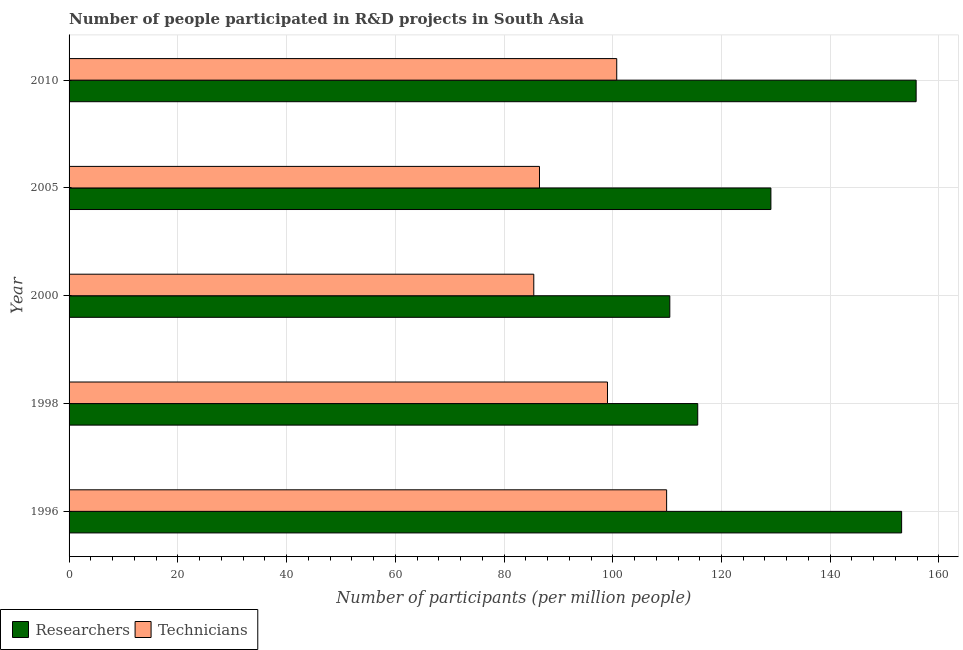How many different coloured bars are there?
Provide a succinct answer. 2. How many groups of bars are there?
Keep it short and to the point. 5. What is the number of technicians in 2010?
Give a very brief answer. 100.73. Across all years, what is the maximum number of researchers?
Provide a short and direct response. 155.8. Across all years, what is the minimum number of technicians?
Provide a succinct answer. 85.47. What is the total number of researchers in the graph?
Your answer should be very brief. 664.15. What is the difference between the number of technicians in 1996 and that in 2005?
Your answer should be very brief. 23.39. What is the difference between the number of researchers in 2010 and the number of technicians in 2000?
Offer a very short reply. 70.33. What is the average number of technicians per year?
Ensure brevity in your answer.  96.33. In the year 1996, what is the difference between the number of technicians and number of researchers?
Offer a terse response. -43.22. In how many years, is the number of researchers greater than 72 ?
Provide a succinct answer. 5. What is the ratio of the number of technicians in 1996 to that in 2000?
Provide a short and direct response. 1.29. Is the number of technicians in 2000 less than that in 2005?
Provide a short and direct response. Yes. Is the difference between the number of researchers in 1996 and 2000 greater than the difference between the number of technicians in 1996 and 2000?
Keep it short and to the point. Yes. What is the difference between the highest and the second highest number of researchers?
Your response must be concise. 2.67. What is the difference between the highest and the lowest number of technicians?
Offer a very short reply. 24.44. In how many years, is the number of technicians greater than the average number of technicians taken over all years?
Keep it short and to the point. 3. What does the 1st bar from the top in 2000 represents?
Your answer should be compact. Technicians. What does the 2nd bar from the bottom in 2000 represents?
Give a very brief answer. Technicians. How many bars are there?
Your answer should be very brief. 10. Does the graph contain any zero values?
Your answer should be compact. No. Does the graph contain grids?
Your answer should be very brief. Yes. How many legend labels are there?
Provide a short and direct response. 2. What is the title of the graph?
Give a very brief answer. Number of people participated in R&D projects in South Asia. What is the label or title of the X-axis?
Your answer should be very brief. Number of participants (per million people). What is the label or title of the Y-axis?
Offer a very short reply. Year. What is the Number of participants (per million people) of Researchers in 1996?
Offer a very short reply. 153.13. What is the Number of participants (per million people) in Technicians in 1996?
Provide a succinct answer. 109.91. What is the Number of participants (per million people) in Researchers in 1998?
Offer a very short reply. 115.63. What is the Number of participants (per million people) of Technicians in 1998?
Offer a terse response. 99.03. What is the Number of participants (per million people) in Researchers in 2000?
Ensure brevity in your answer.  110.5. What is the Number of participants (per million people) in Technicians in 2000?
Provide a succinct answer. 85.47. What is the Number of participants (per million people) of Researchers in 2005?
Your response must be concise. 129.09. What is the Number of participants (per million people) in Technicians in 2005?
Make the answer very short. 86.52. What is the Number of participants (per million people) of Researchers in 2010?
Provide a short and direct response. 155.8. What is the Number of participants (per million people) in Technicians in 2010?
Your answer should be very brief. 100.73. Across all years, what is the maximum Number of participants (per million people) in Researchers?
Provide a succinct answer. 155.8. Across all years, what is the maximum Number of participants (per million people) of Technicians?
Offer a very short reply. 109.91. Across all years, what is the minimum Number of participants (per million people) in Researchers?
Your answer should be compact. 110.5. Across all years, what is the minimum Number of participants (per million people) in Technicians?
Your response must be concise. 85.47. What is the total Number of participants (per million people) of Researchers in the graph?
Keep it short and to the point. 664.15. What is the total Number of participants (per million people) in Technicians in the graph?
Offer a very short reply. 481.67. What is the difference between the Number of participants (per million people) of Researchers in 1996 and that in 1998?
Ensure brevity in your answer.  37.5. What is the difference between the Number of participants (per million people) in Technicians in 1996 and that in 1998?
Ensure brevity in your answer.  10.88. What is the difference between the Number of participants (per million people) of Researchers in 1996 and that in 2000?
Provide a short and direct response. 42.63. What is the difference between the Number of participants (per million people) in Technicians in 1996 and that in 2000?
Ensure brevity in your answer.  24.44. What is the difference between the Number of participants (per million people) in Researchers in 1996 and that in 2005?
Provide a short and direct response. 24.04. What is the difference between the Number of participants (per million people) of Technicians in 1996 and that in 2005?
Provide a short and direct response. 23.39. What is the difference between the Number of participants (per million people) of Researchers in 1996 and that in 2010?
Your answer should be very brief. -2.67. What is the difference between the Number of participants (per million people) of Technicians in 1996 and that in 2010?
Your answer should be very brief. 9.18. What is the difference between the Number of participants (per million people) of Researchers in 1998 and that in 2000?
Ensure brevity in your answer.  5.14. What is the difference between the Number of participants (per million people) of Technicians in 1998 and that in 2000?
Offer a terse response. 13.56. What is the difference between the Number of participants (per million people) of Researchers in 1998 and that in 2005?
Offer a very short reply. -13.46. What is the difference between the Number of participants (per million people) of Technicians in 1998 and that in 2005?
Provide a short and direct response. 12.51. What is the difference between the Number of participants (per million people) in Researchers in 1998 and that in 2010?
Provide a succinct answer. -40.17. What is the difference between the Number of participants (per million people) in Technicians in 1998 and that in 2010?
Offer a very short reply. -1.7. What is the difference between the Number of participants (per million people) of Researchers in 2000 and that in 2005?
Make the answer very short. -18.59. What is the difference between the Number of participants (per million people) in Technicians in 2000 and that in 2005?
Your answer should be very brief. -1.05. What is the difference between the Number of participants (per million people) in Researchers in 2000 and that in 2010?
Make the answer very short. -45.31. What is the difference between the Number of participants (per million people) in Technicians in 2000 and that in 2010?
Provide a succinct answer. -15.26. What is the difference between the Number of participants (per million people) of Researchers in 2005 and that in 2010?
Provide a short and direct response. -26.71. What is the difference between the Number of participants (per million people) of Technicians in 2005 and that in 2010?
Offer a terse response. -14.21. What is the difference between the Number of participants (per million people) of Researchers in 1996 and the Number of participants (per million people) of Technicians in 1998?
Give a very brief answer. 54.1. What is the difference between the Number of participants (per million people) in Researchers in 1996 and the Number of participants (per million people) in Technicians in 2000?
Offer a very short reply. 67.66. What is the difference between the Number of participants (per million people) of Researchers in 1996 and the Number of participants (per million people) of Technicians in 2005?
Keep it short and to the point. 66.61. What is the difference between the Number of participants (per million people) in Researchers in 1996 and the Number of participants (per million people) in Technicians in 2010?
Ensure brevity in your answer.  52.4. What is the difference between the Number of participants (per million people) in Researchers in 1998 and the Number of participants (per million people) in Technicians in 2000?
Give a very brief answer. 30.16. What is the difference between the Number of participants (per million people) of Researchers in 1998 and the Number of participants (per million people) of Technicians in 2005?
Ensure brevity in your answer.  29.11. What is the difference between the Number of participants (per million people) in Researchers in 1998 and the Number of participants (per million people) in Technicians in 2010?
Your answer should be compact. 14.9. What is the difference between the Number of participants (per million people) in Researchers in 2000 and the Number of participants (per million people) in Technicians in 2005?
Offer a terse response. 23.97. What is the difference between the Number of participants (per million people) of Researchers in 2000 and the Number of participants (per million people) of Technicians in 2010?
Provide a short and direct response. 9.76. What is the difference between the Number of participants (per million people) of Researchers in 2005 and the Number of participants (per million people) of Technicians in 2010?
Keep it short and to the point. 28.36. What is the average Number of participants (per million people) in Researchers per year?
Offer a very short reply. 132.83. What is the average Number of participants (per million people) of Technicians per year?
Ensure brevity in your answer.  96.33. In the year 1996, what is the difference between the Number of participants (per million people) of Researchers and Number of participants (per million people) of Technicians?
Your answer should be compact. 43.22. In the year 1998, what is the difference between the Number of participants (per million people) in Researchers and Number of participants (per million people) in Technicians?
Provide a succinct answer. 16.6. In the year 2000, what is the difference between the Number of participants (per million people) in Researchers and Number of participants (per million people) in Technicians?
Give a very brief answer. 25.02. In the year 2005, what is the difference between the Number of participants (per million people) of Researchers and Number of participants (per million people) of Technicians?
Offer a very short reply. 42.57. In the year 2010, what is the difference between the Number of participants (per million people) in Researchers and Number of participants (per million people) in Technicians?
Offer a very short reply. 55.07. What is the ratio of the Number of participants (per million people) in Researchers in 1996 to that in 1998?
Offer a very short reply. 1.32. What is the ratio of the Number of participants (per million people) of Technicians in 1996 to that in 1998?
Your response must be concise. 1.11. What is the ratio of the Number of participants (per million people) of Researchers in 1996 to that in 2000?
Your answer should be compact. 1.39. What is the ratio of the Number of participants (per million people) of Technicians in 1996 to that in 2000?
Provide a short and direct response. 1.29. What is the ratio of the Number of participants (per million people) in Researchers in 1996 to that in 2005?
Make the answer very short. 1.19. What is the ratio of the Number of participants (per million people) in Technicians in 1996 to that in 2005?
Your answer should be compact. 1.27. What is the ratio of the Number of participants (per million people) of Researchers in 1996 to that in 2010?
Ensure brevity in your answer.  0.98. What is the ratio of the Number of participants (per million people) of Technicians in 1996 to that in 2010?
Ensure brevity in your answer.  1.09. What is the ratio of the Number of participants (per million people) of Researchers in 1998 to that in 2000?
Offer a very short reply. 1.05. What is the ratio of the Number of participants (per million people) in Technicians in 1998 to that in 2000?
Your answer should be very brief. 1.16. What is the ratio of the Number of participants (per million people) of Researchers in 1998 to that in 2005?
Offer a terse response. 0.9. What is the ratio of the Number of participants (per million people) in Technicians in 1998 to that in 2005?
Your response must be concise. 1.14. What is the ratio of the Number of participants (per million people) of Researchers in 1998 to that in 2010?
Keep it short and to the point. 0.74. What is the ratio of the Number of participants (per million people) of Technicians in 1998 to that in 2010?
Ensure brevity in your answer.  0.98. What is the ratio of the Number of participants (per million people) in Researchers in 2000 to that in 2005?
Give a very brief answer. 0.86. What is the ratio of the Number of participants (per million people) of Technicians in 2000 to that in 2005?
Ensure brevity in your answer.  0.99. What is the ratio of the Number of participants (per million people) of Researchers in 2000 to that in 2010?
Keep it short and to the point. 0.71. What is the ratio of the Number of participants (per million people) in Technicians in 2000 to that in 2010?
Give a very brief answer. 0.85. What is the ratio of the Number of participants (per million people) of Researchers in 2005 to that in 2010?
Your answer should be very brief. 0.83. What is the ratio of the Number of participants (per million people) in Technicians in 2005 to that in 2010?
Ensure brevity in your answer.  0.86. What is the difference between the highest and the second highest Number of participants (per million people) in Researchers?
Make the answer very short. 2.67. What is the difference between the highest and the second highest Number of participants (per million people) in Technicians?
Offer a very short reply. 9.18. What is the difference between the highest and the lowest Number of participants (per million people) in Researchers?
Offer a terse response. 45.31. What is the difference between the highest and the lowest Number of participants (per million people) in Technicians?
Offer a terse response. 24.44. 